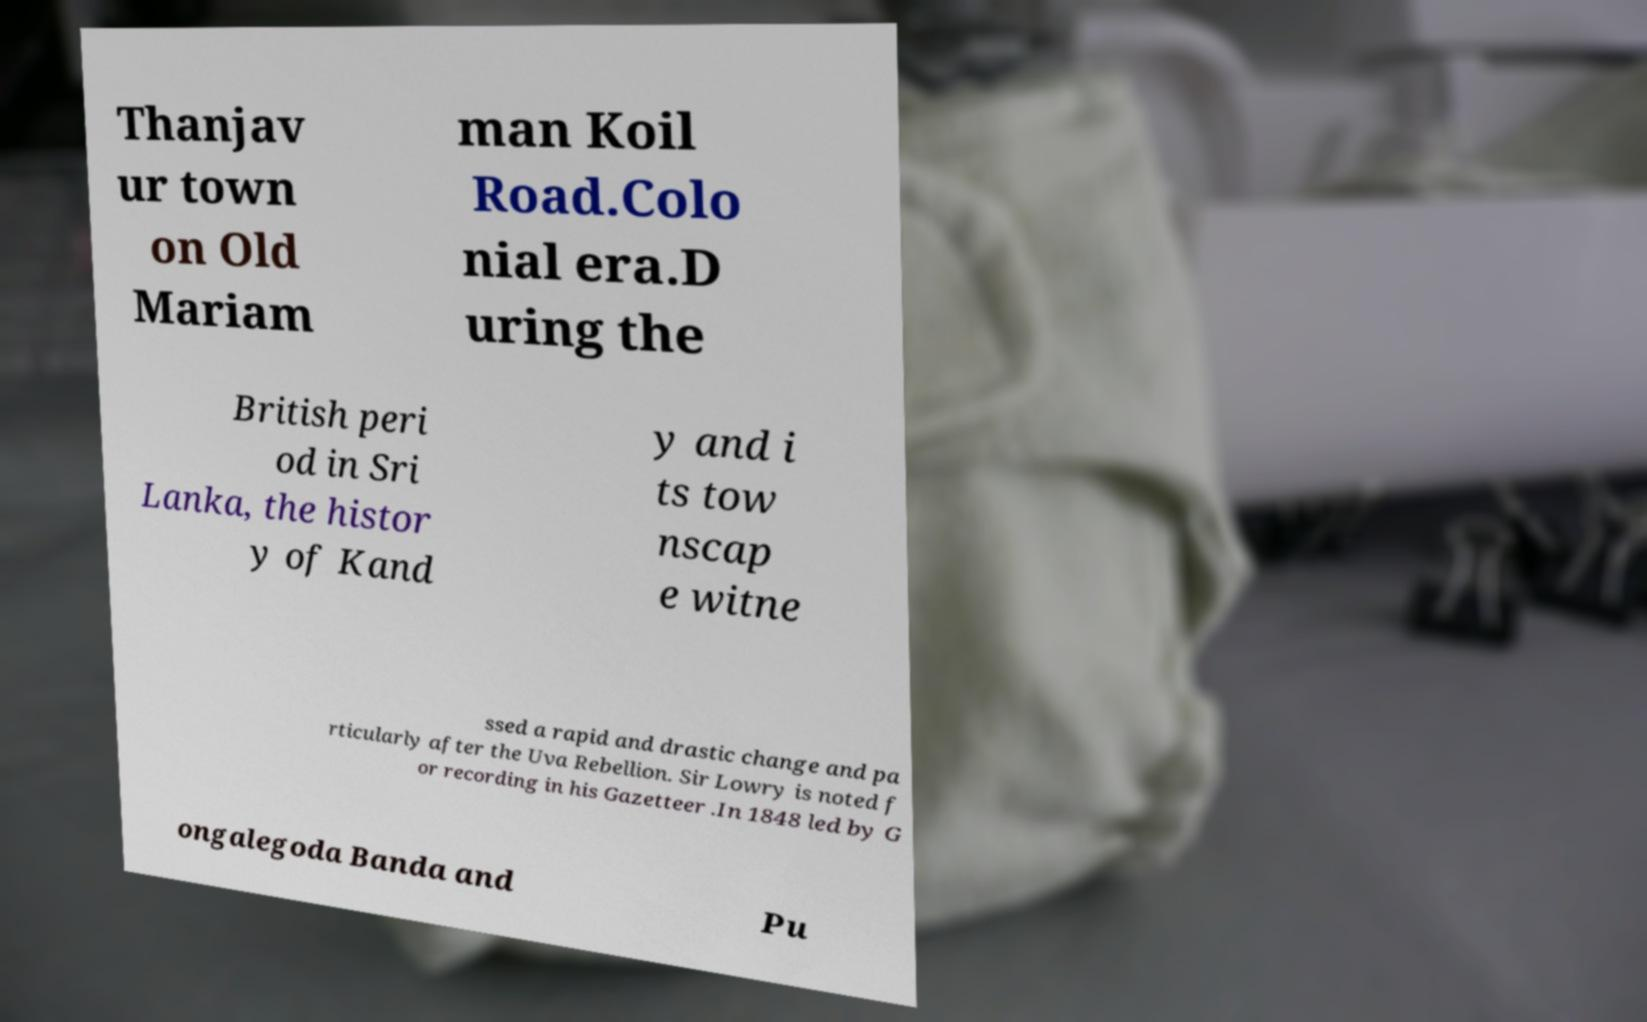Please read and relay the text visible in this image. What does it say? Thanjav ur town on Old Mariam man Koil Road.Colo nial era.D uring the British peri od in Sri Lanka, the histor y of Kand y and i ts tow nscap e witne ssed a rapid and drastic change and pa rticularly after the Uva Rebellion. Sir Lowry is noted f or recording in his Gazetteer .In 1848 led by G ongalegoda Banda and Pu 